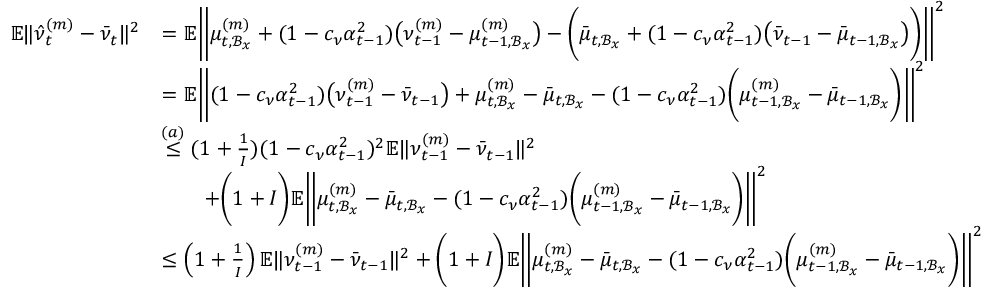<formula> <loc_0><loc_0><loc_500><loc_500>\begin{array} { r l } { \mathbb { E } \| \hat { \nu } _ { t } ^ { ( m ) } - \bar { \nu } _ { t } \| ^ { 2 } } & { = \mathbb { E } \left \| \mu _ { t , \mathcal { B } _ { x } } ^ { ( m ) } + ( 1 - c _ { \nu } \alpha _ { t - 1 } ^ { 2 } ) \left ( \nu _ { t - 1 } ^ { ( m ) } - \mu _ { t - 1 , \mathcal { B } _ { x } } ^ { ( m ) } \right ) - \left ( \bar { \mu } _ { t , \mathcal { B } _ { x } } + ( 1 - c _ { \nu } \alpha _ { t - 1 } ^ { 2 } ) \left ( \bar { \nu } _ { t - 1 } - \bar { \mu } _ { t - 1 , \mathcal { B } _ { x } } \right ) \right ) \right \| ^ { 2 } } \\ & { = \mathbb { E } \left \| ( 1 - c _ { \nu } \alpha _ { t - 1 } ^ { 2 } ) \left ( \nu _ { t - 1 } ^ { ( m ) } - \bar { \nu } _ { t - 1 } \right ) + \mu _ { t , \mathcal { B } _ { x } } ^ { ( m ) } - \bar { \mu } _ { t , \mathcal { B } _ { x } } - ( 1 - c _ { \nu } \alpha _ { t - 1 } ^ { 2 } ) \left ( \mu _ { t - 1 , \mathcal { B } _ { x } } ^ { ( m ) } - \bar { \mu } _ { t - 1 , \mathcal { B } _ { x } } \right ) \right \| ^ { 2 } } \\ & { \overset { ( a ) } { \leq } ( 1 + \frac { 1 } { I } ) ( 1 - c _ { \nu } \alpha _ { t - 1 } ^ { 2 } ) ^ { 2 } \mathbb { E } \| \nu _ { t - 1 } ^ { ( m ) } - \bar { \nu } _ { t - 1 } \| ^ { 2 } } \\ & { \quad + \left ( 1 + I \right ) \mathbb { E } \left \| \mu _ { t , \mathcal { B } _ { x } } ^ { ( m ) } - \bar { \mu } _ { t , \mathcal { B } _ { x } } - ( 1 - c _ { \nu } \alpha _ { t - 1 } ^ { 2 } ) \left ( \mu _ { t - 1 , \mathcal { B } _ { x } } ^ { ( m ) } - \bar { \mu } _ { t - 1 , \mathcal { B } _ { x } } \right ) \right \| ^ { 2 } } \\ & { \leq \left ( 1 + \frac { 1 } { I } \right ) \mathbb { E } \| \nu _ { t - 1 } ^ { ( m ) } - \bar { \nu } _ { t - 1 } \| ^ { 2 } + \left ( 1 + I \right ) \mathbb { E } \left \| \mu _ { t , \mathcal { B } _ { x } } ^ { ( m ) } - \bar { \mu } _ { t , \mathcal { B } _ { x } } - ( 1 - c _ { \nu } \alpha _ { t - 1 } ^ { 2 } ) \left ( \mu _ { t - 1 , \mathcal { B } _ { x } } ^ { ( m ) } - \bar { \mu } _ { t - 1 , \mathcal { B } _ { x } } \right ) \right \| ^ { 2 } } \end{array}</formula> 